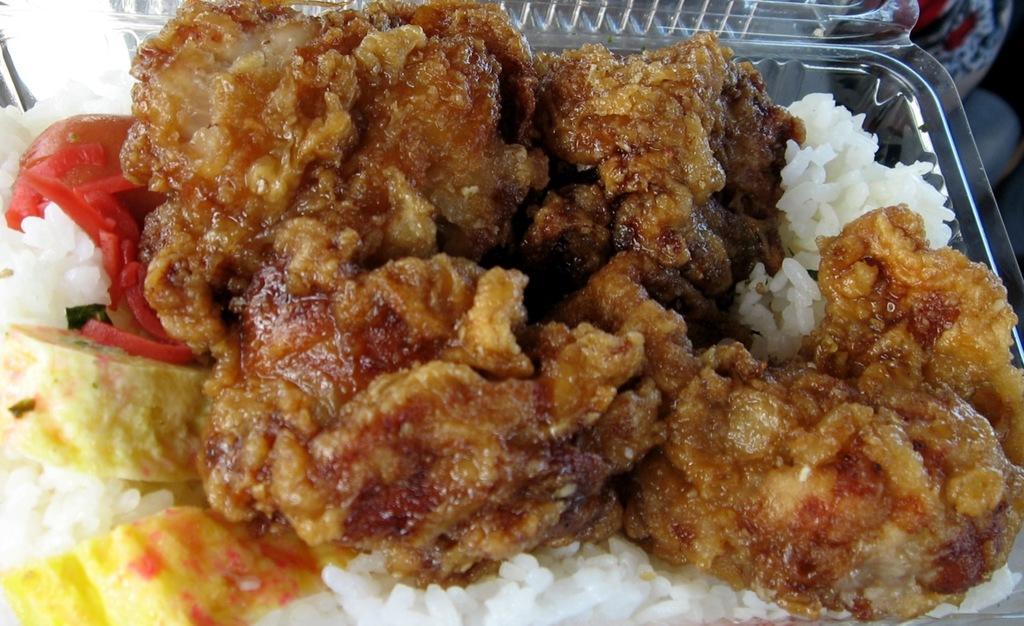Please provide a concise description of this image. In this picture we can see food in a box and in the background we can see an object. 